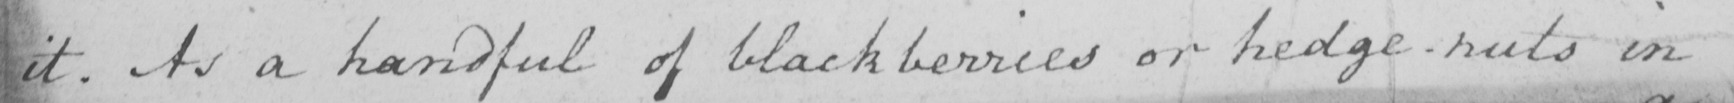Can you read and transcribe this handwriting? it . As a handful of blackberries or hedge-nuts in 